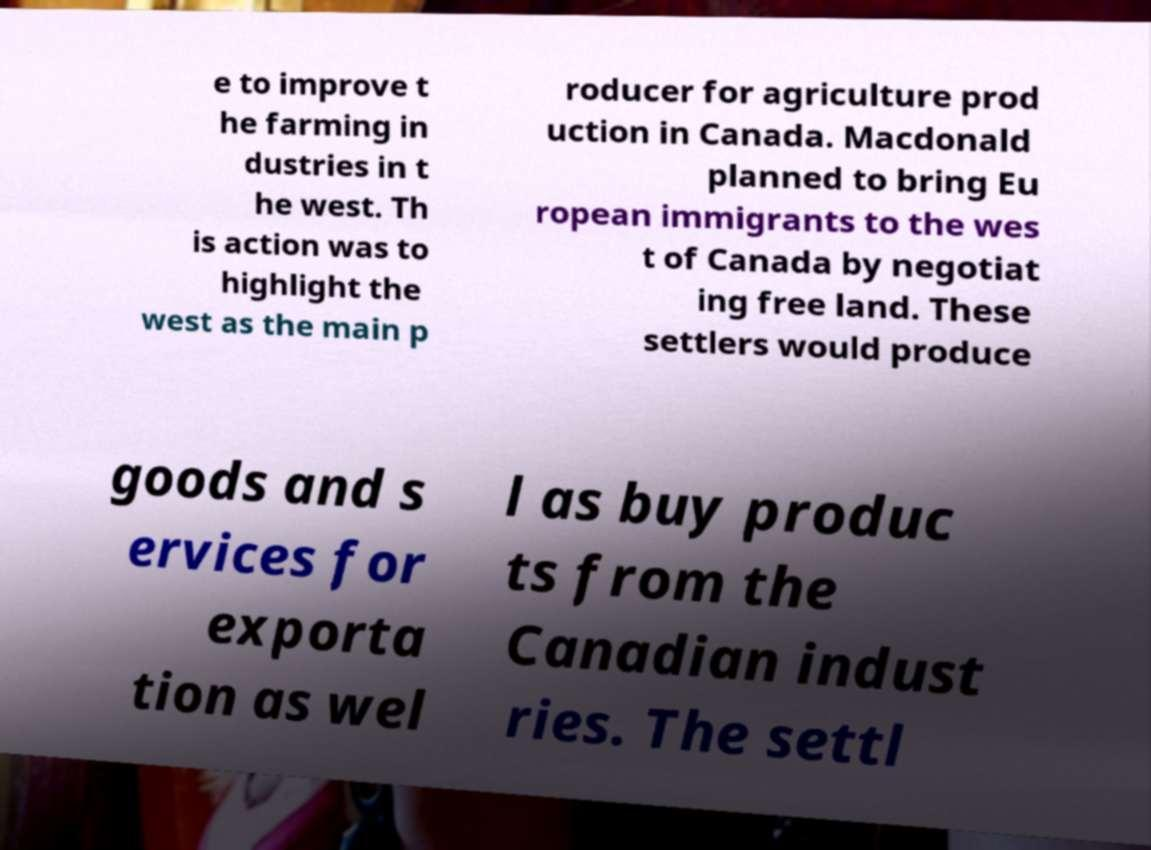What messages or text are displayed in this image? I need them in a readable, typed format. e to improve t he farming in dustries in t he west. Th is action was to highlight the west as the main p roducer for agriculture prod uction in Canada. Macdonald planned to bring Eu ropean immigrants to the wes t of Canada by negotiat ing free land. These settlers would produce goods and s ervices for exporta tion as wel l as buy produc ts from the Canadian indust ries. The settl 